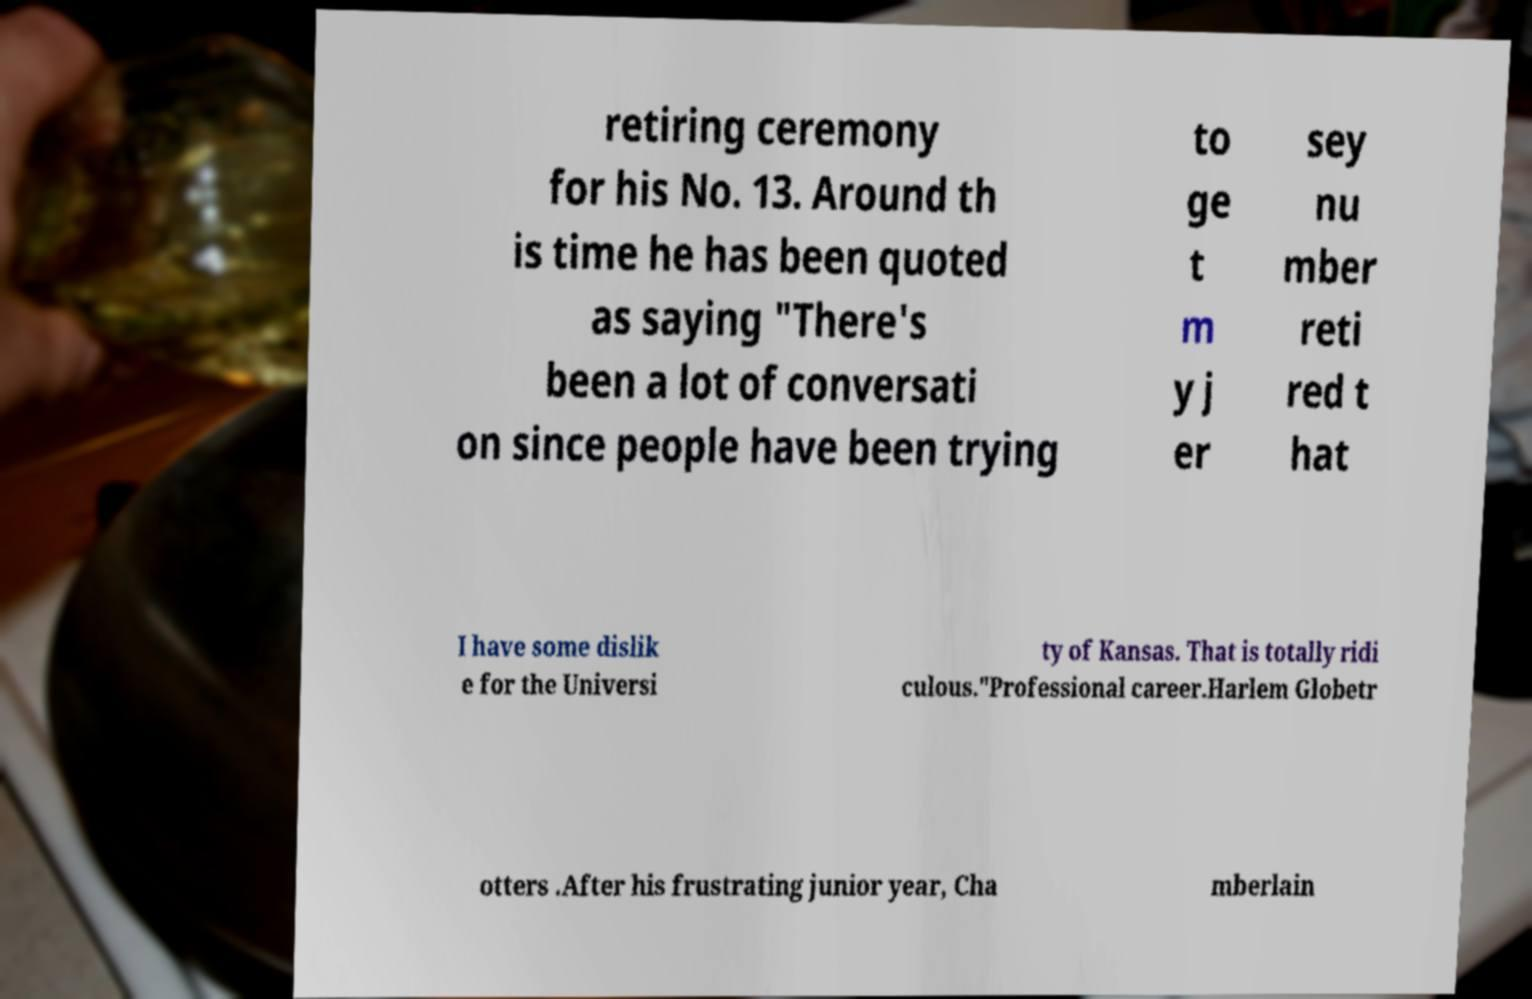Could you extract and type out the text from this image? retiring ceremony for his No. 13. Around th is time he has been quoted as saying "There's been a lot of conversati on since people have been trying to ge t m y j er sey nu mber reti red t hat I have some dislik e for the Universi ty of Kansas. That is totally ridi culous."Professional career.Harlem Globetr otters .After his frustrating junior year, Cha mberlain 